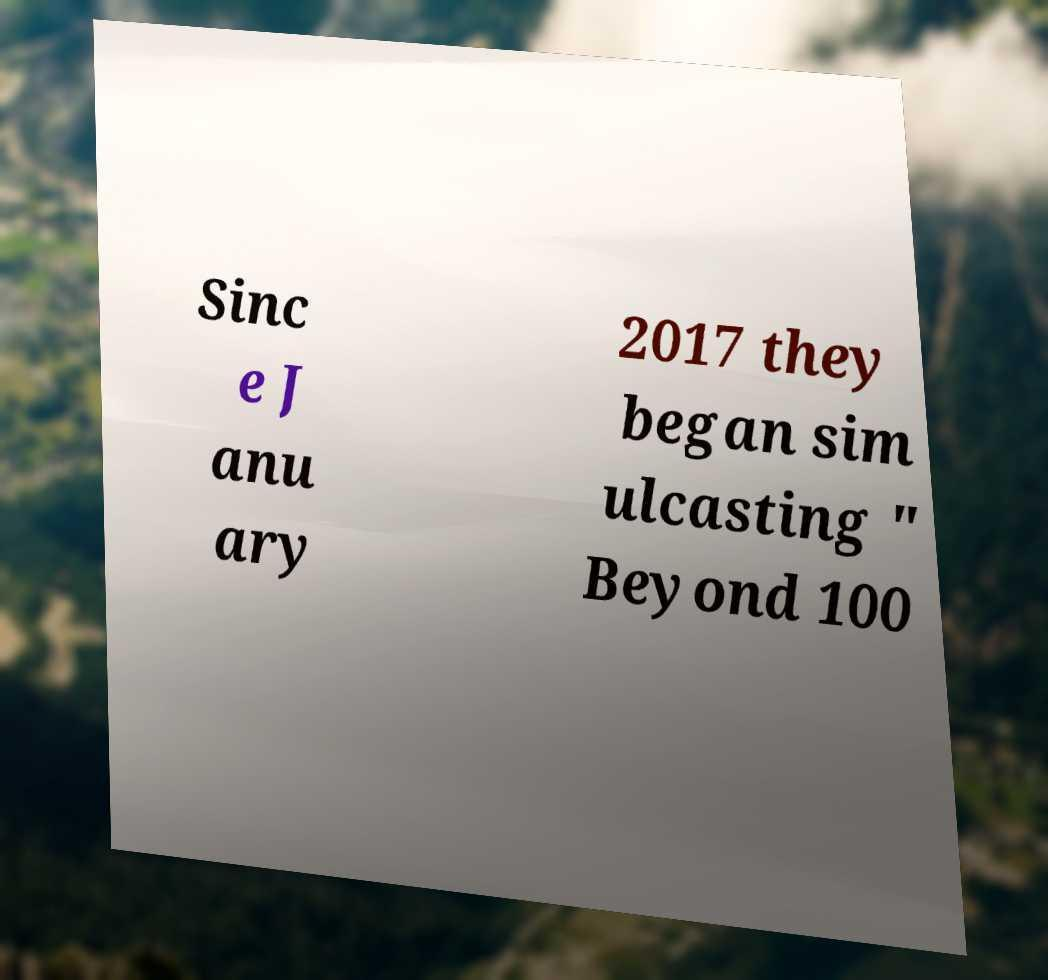I need the written content from this picture converted into text. Can you do that? Sinc e J anu ary 2017 they began sim ulcasting " Beyond 100 